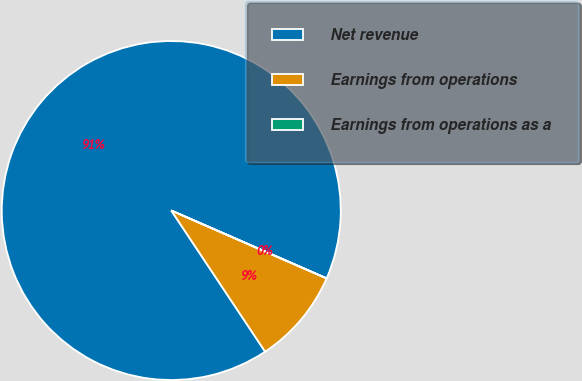Convert chart to OTSL. <chart><loc_0><loc_0><loc_500><loc_500><pie_chart><fcel>Net revenue<fcel>Earnings from operations<fcel>Earnings from operations as a<nl><fcel>90.89%<fcel>9.1%<fcel>0.01%<nl></chart> 